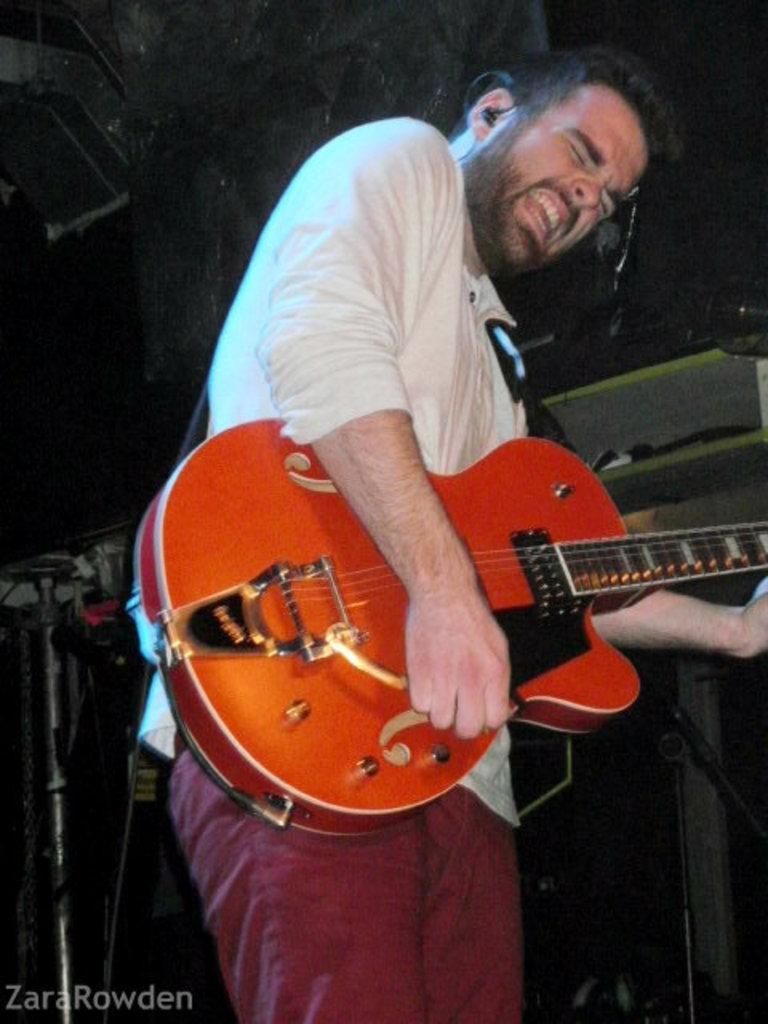Describe this image in one or two sentences. in this image I can see a man is standing and holding a guitar. 